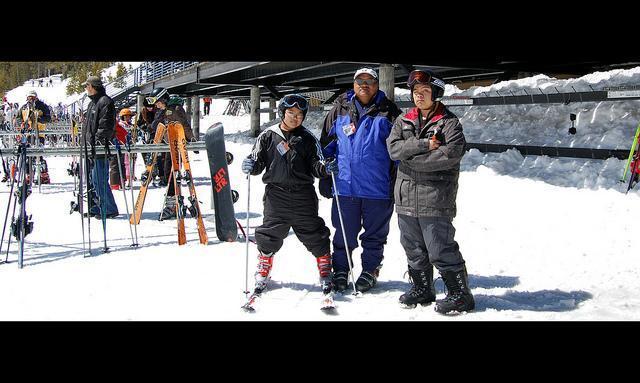How many of the three people are wearing skis?
Give a very brief answer. 1. How many people are there?
Give a very brief answer. 4. How many tracks have a train on them?
Give a very brief answer. 0. 